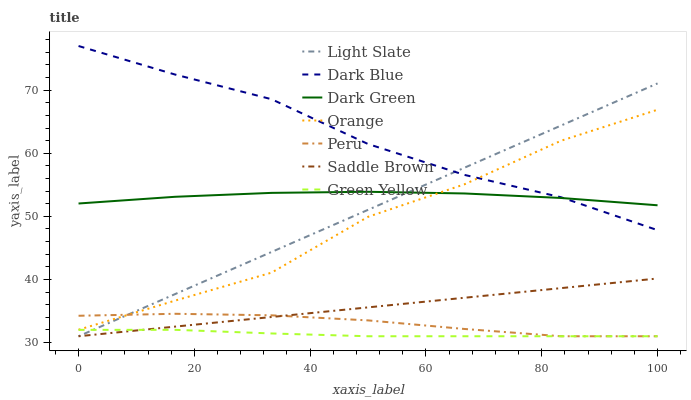Does Green Yellow have the minimum area under the curve?
Answer yes or no. Yes. Does Dark Blue have the maximum area under the curve?
Answer yes or no. Yes. Does Peru have the minimum area under the curve?
Answer yes or no. No. Does Peru have the maximum area under the curve?
Answer yes or no. No. Is Saddle Brown the smoothest?
Answer yes or no. Yes. Is Orange the roughest?
Answer yes or no. Yes. Is Dark Blue the smoothest?
Answer yes or no. No. Is Dark Blue the roughest?
Answer yes or no. No. Does Light Slate have the lowest value?
Answer yes or no. Yes. Does Dark Blue have the lowest value?
Answer yes or no. No. Does Dark Blue have the highest value?
Answer yes or no. Yes. Does Peru have the highest value?
Answer yes or no. No. Is Saddle Brown less than Dark Blue?
Answer yes or no. Yes. Is Dark Green greater than Green Yellow?
Answer yes or no. Yes. Does Saddle Brown intersect Peru?
Answer yes or no. Yes. Is Saddle Brown less than Peru?
Answer yes or no. No. Is Saddle Brown greater than Peru?
Answer yes or no. No. Does Saddle Brown intersect Dark Blue?
Answer yes or no. No. 